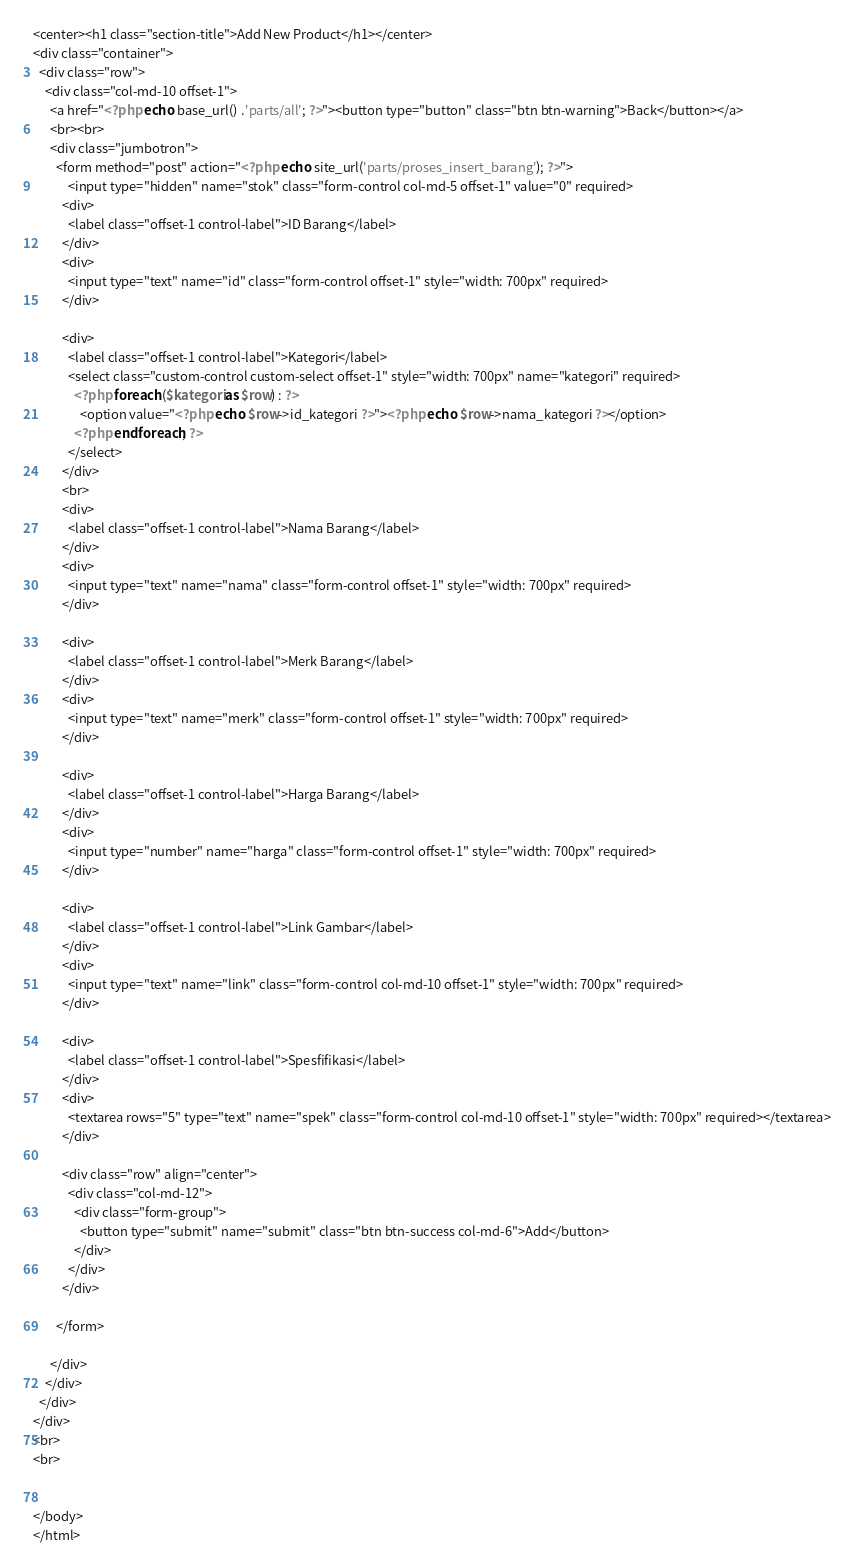<code> <loc_0><loc_0><loc_500><loc_500><_PHP_><center><h1 class="section-title">Add New Product</h1></center>
<div class="container">
  <div class="row">
    <div class="col-md-10 offset-1">
      <a href="<?php echo base_url() .'parts/all'; ?>"><button type="button" class="btn btn-warning">Back</button></a>
      <br><br>
      <div class="jumbotron">
        <form method="post" action="<?php echo site_url('parts/proses_insert_barang'); ?>">
            <input type="hidden" name="stok" class="form-control col-md-5 offset-1" value="0" required>
          <div>
            <label class="offset-1 control-label">ID Barang</label>
          </div>
          <div>
            <input type="text" name="id" class="form-control offset-1" style="width: 700px" required>
          </div>

          <div>
            <label class="offset-1 control-label">Kategori</label>
            <select class="custom-control custom-select offset-1" style="width: 700px" name="kategori" required>
              <?php foreach ($kategori as $row) : ?>
                <option value="<?php echo $row->id_kategori ?>"><?php echo $row->nama_kategori ?></option>
              <?php endforeach; ?>
            </select>
          </div>
          <br>
          <div>
            <label class="offset-1 control-label">Nama Barang</label>
          </div>
          <div>
            <input type="text" name="nama" class="form-control offset-1" style="width: 700px" required>
          </div>

          <div>
            <label class="offset-1 control-label">Merk Barang</label>
          </div>
          <div>
            <input type="text" name="merk" class="form-control offset-1" style="width: 700px" required>
          </div>  

          <div>
            <label class="offset-1 control-label">Harga Barang</label>
          </div>
          <div>
            <input type="number" name="harga" class="form-control offset-1" style="width: 700px" required>
          </div>

          <div>
            <label class="offset-1 control-label">Link Gambar</label>
          </div>
          <div>
            <input type="text" name="link" class="form-control col-md-10 offset-1" style="width: 700px" required>
          </div>

          <div>
            <label class="offset-1 control-label">Spesfifikasi</label>
          </div>
          <div>
            <textarea rows="5" type="text" name="spek" class="form-control col-md-10 offset-1" style="width: 700px" required></textarea>
          </div>
          
          <div class="row" align="center">
            <div class="col-md-12">
              <div class="form-group">
                <button type="submit" name="submit" class="btn btn-success col-md-6">Add</button>
              </div>
            </div>
          </div>

        </form>

      </div>
    </div>
  </div>
</div>
<br>
<br>


</body>
</html></code> 